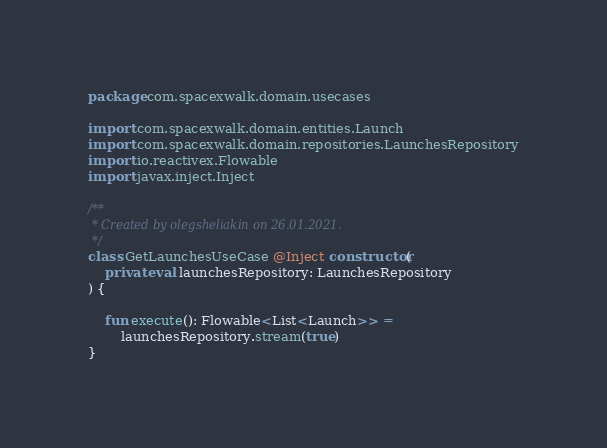Convert code to text. <code><loc_0><loc_0><loc_500><loc_500><_Kotlin_>package com.spacexwalk.domain.usecases

import com.spacexwalk.domain.entities.Launch
import com.spacexwalk.domain.repositories.LaunchesRepository
import io.reactivex.Flowable
import javax.inject.Inject

/**
 * Created by olegsheliakin on 26.01.2021.
 */
class GetLaunchesUseCase @Inject constructor(
    private val launchesRepository: LaunchesRepository
) {

    fun execute(): Flowable<List<Launch>> =
        launchesRepository.stream(true)
}
</code> 